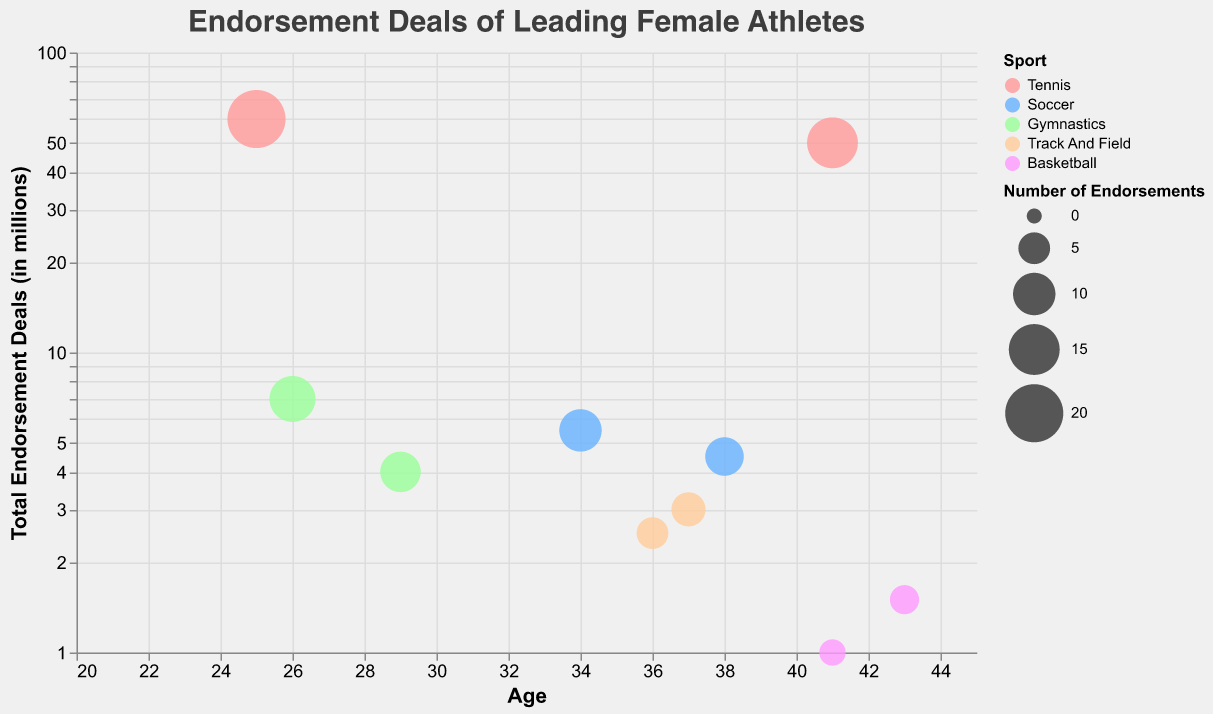What is the title of the chart? The title can be found at the top of the chart, prominently displayed. It reads "Endorsement Deals of Leading Female Athletes".
Answer: Endorsement Deals of Leading Female Athletes How many athletes are represented in the chart? To determine the number of athletes, you count each individual data point (each bubble) on the chart.
Answer: 10 Which sport has the highest total endorsement deals value represented by an athlete? Locate the bubble highest on the y-axis, which represents total endorsement deals. The tooltip or legend can confirm the sport.
Answer: Tennis Which athlete has the largest number of endorsements? The size of the bubbles represents the number of endorsements. The largest bubble indicates the athlete with the most endorsements.
Answer: Naomi Osaka Compare the total endorsement deals between tennis and soccer athletes. Who has the highest value in each sport? Identify the highest bubble in each color representing tennis and soccer on the y-axis. For tennis, it is the pink bubble and for soccer, it is the blue bubble.
Answer: Tennis: Naomi Osaka, Soccer: Alex Morgan What is the average number of endorsements among all athletes? Add the number of endorsements for all athletes and divide by the total number of athletes: (15 + 20 + 8 + 10 + 12 + 9 + 6 + 5 + 4 + 3)/10 = 9.2.
Answer: 9.2 Which athlete is the youngest and what sport do they play? Locate the bubble farthest to the left on the x-axis, which represents age. The tooltip will provide the athlete's name and sport.
Answer: Naomi Osaka, Tennis Is there any correlation between an athlete's age and the total endorsement deals value? Observe the trend of bubble positions regarding age on the x-axis and endorsement deals on the y-axis. The trend appears scattered.
Answer: No clear correlation Compare the total endorsement deals of Allyson Felix and Shelly-Ann Fraser-Pryce. Who has more, and by how much? Locate both bubbles on the chart by their names through the tooltip. Allyson Felix's bubble is higher on the y-axis (3 million) than Shelly-Ann Fraser-Pryce's (2.5 million). 3 - 2.5 = 0.5 million difference.
Answer: Allyson Felix, by 0.5 million 